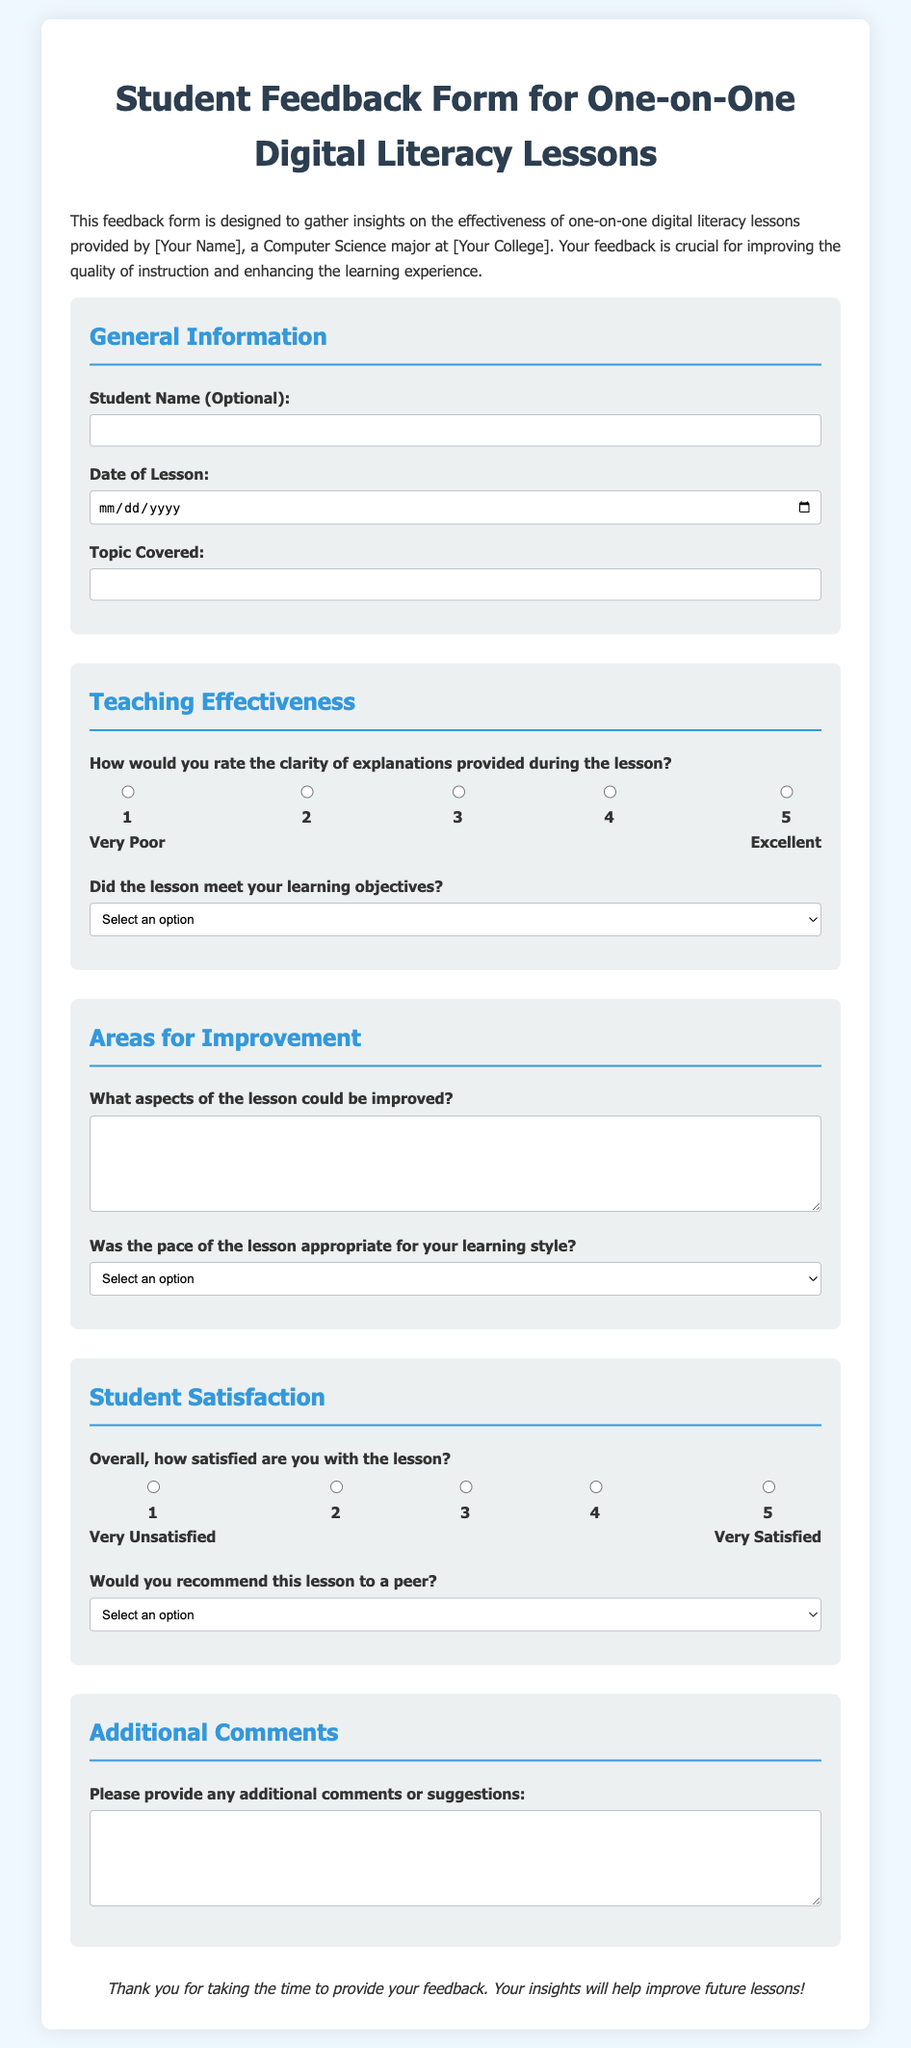What is the title of the document? The title is presented at the top of the document and states what the form is for.
Answer: Student Feedback Form for One-on-One Digital Literacy Lessons Who is the intended recipient of the feedback? The document states that the feedback is for lessons provided by the individual named in the form.
Answer: [Your Name] What is the purpose of the feedback form? The purpose is outlined in the initial paragraph explaining the need for insights on teaching effectiveness.
Answer: To gather insights on the effectiveness of one-on-one digital literacy lessons How many sections are there in the feedback form? The sections are clearly numbered in the document, categorized under different topics.
Answer: Four What scale is used to rate satisfaction? The rating system is indicated alongside satisfaction-related questions; it uses a scale of 1 to 5.
Answer: 1 to 5 Which options are available for the lesson pacing question? The available answers provide feedback on the pace of the lesson as part of quality assessment.
Answer: Too Fast, Just Right, Too Slow What aspect of the lesson could be improved according to the feedback form? This is a specific, open-ended feedback question for students to provide their insights.
Answer: What aspects of the lesson could be improved? Does the form ask if the lesson met learning objectives? There is a specific question that addresses whether the lesson met expectations.
Answer: Yes, it does What type of feedback does the form seek in the 'Additional Comments' section? This question gives students a chance to provide further insights or suggestions about the lesson beyond structured questions.
Answer: Additional comments or suggestions 